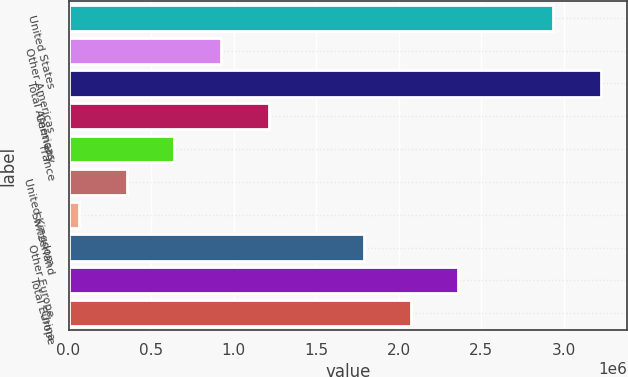Convert chart. <chart><loc_0><loc_0><loc_500><loc_500><bar_chart><fcel>United States<fcel>Other Americas<fcel>Total Americas<fcel>Germany<fcel>France<fcel>United Kingdom<fcel>Switzerland<fcel>Other Europe<fcel>Total Europe<fcel>China<nl><fcel>2.93559e+06<fcel>926440<fcel>3.22261e+06<fcel>1.21346e+06<fcel>639419<fcel>352398<fcel>65377<fcel>1.7875e+06<fcel>2.36154e+06<fcel>2.07452e+06<nl></chart> 